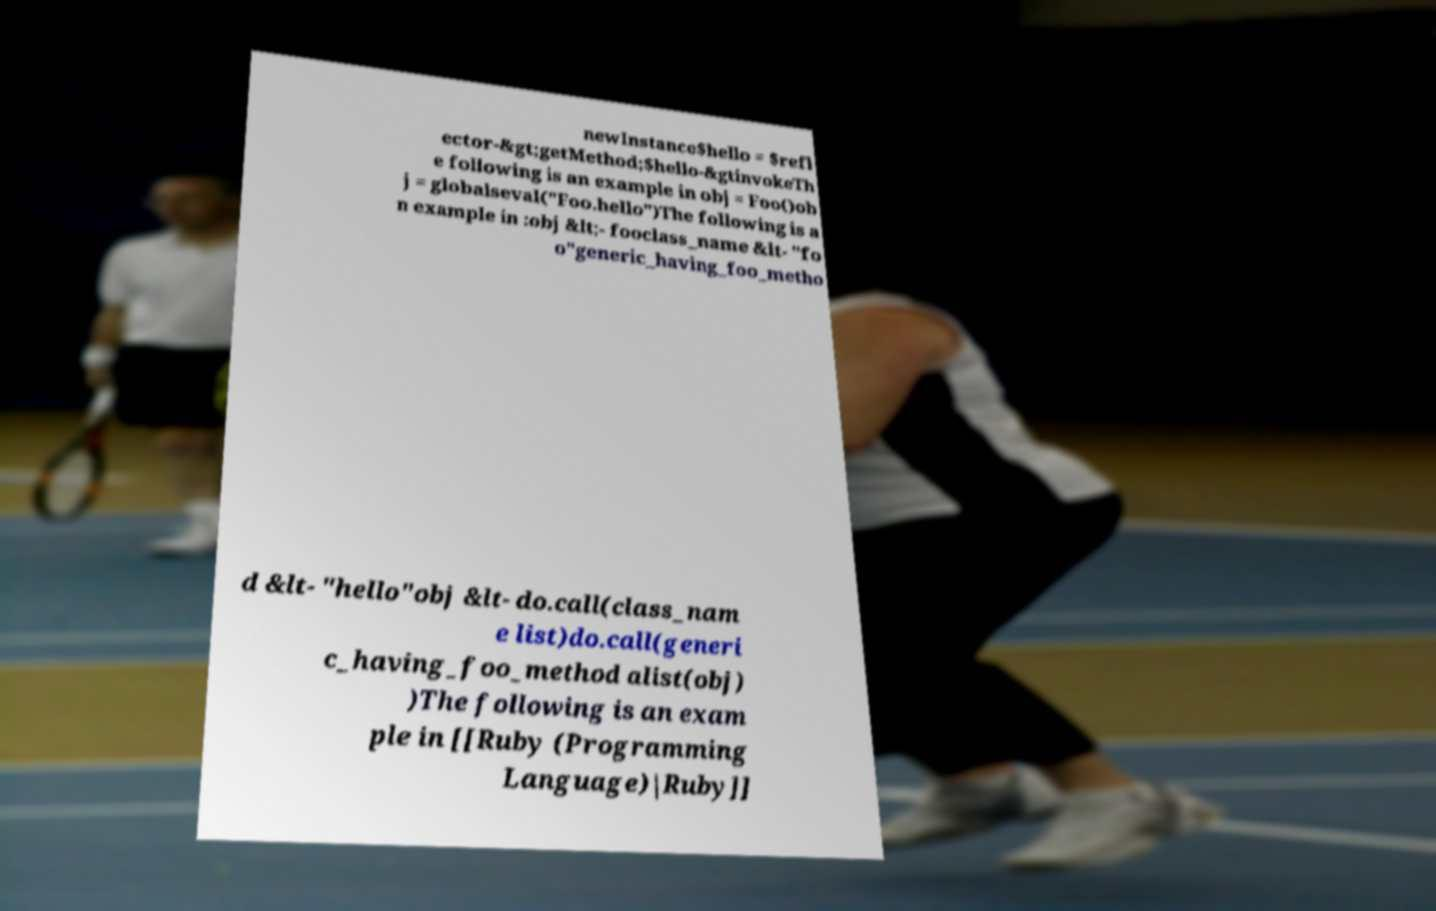Can you accurately transcribe the text from the provided image for me? newInstance$hello = $refl ector-&gt;getMethod;$hello-&gtinvokeTh e following is an example in obj = Foo()ob j = globalseval("Foo.hello")The following is a n example in :obj &lt;- fooclass_name &lt- "fo o"generic_having_foo_metho d &lt- "hello"obj &lt- do.call(class_nam e list)do.call(generi c_having_foo_method alist(obj) )The following is an exam ple in [[Ruby (Programming Language)|Ruby]] 